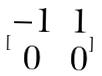<formula> <loc_0><loc_0><loc_500><loc_500>[ \begin{matrix} - 1 & 1 \\ 0 & 0 \end{matrix} ]</formula> 